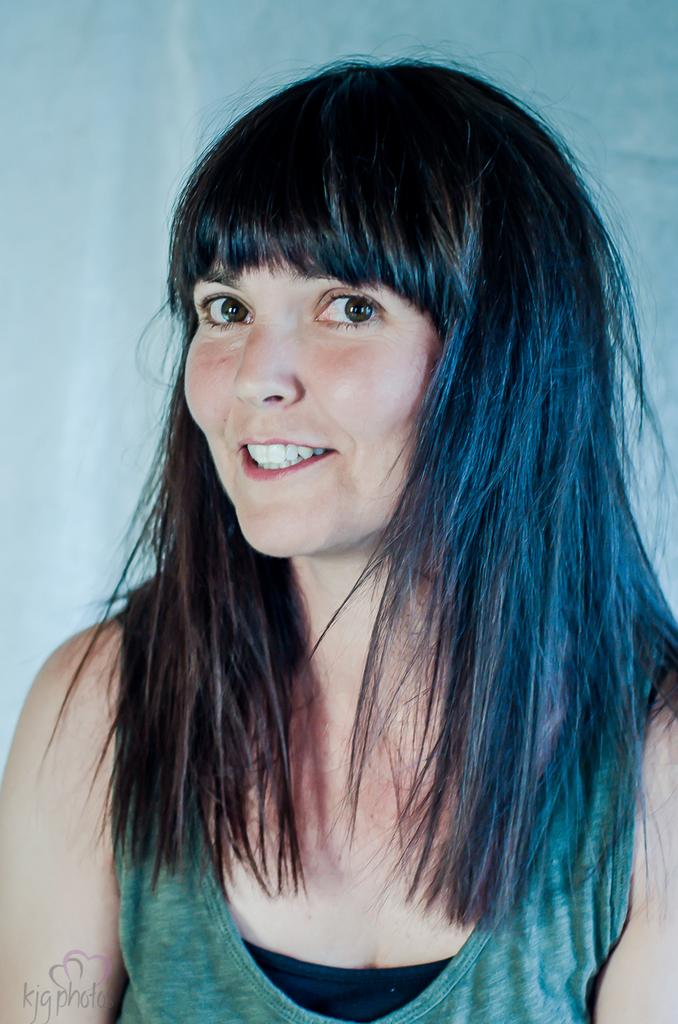Who is present in the image? There is a woman in the image. What is the woman's expression? The woman is smiling. What is the woman wearing? The woman is wearing a green and black dress. What can be seen in the background of the image? There is a wall in the background of the image. Is the wall a part of the scene or a watermark on the image? The wall might be a watermark on the image. What type of net is being used by the woman in the image? There is no net present in the image. Is the woman wearing a veil in the image? The woman is not wearing a veil in the image; she is wearing a green and black dress. 